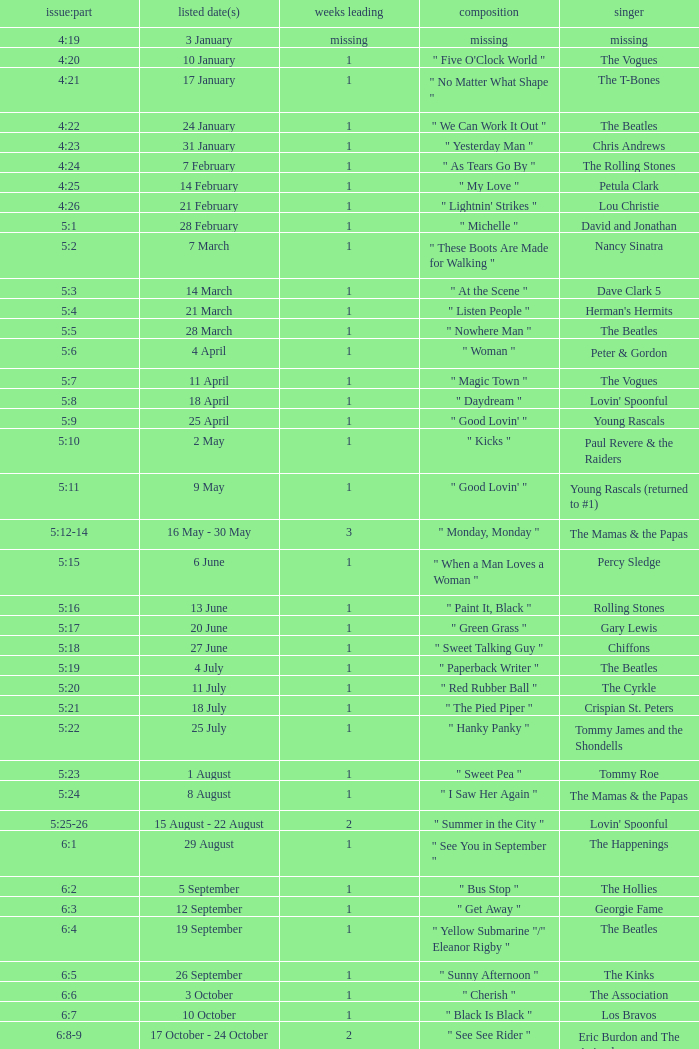With an issue date(s) of 12 September, what is in the column for Weeks on Top? 1.0. 